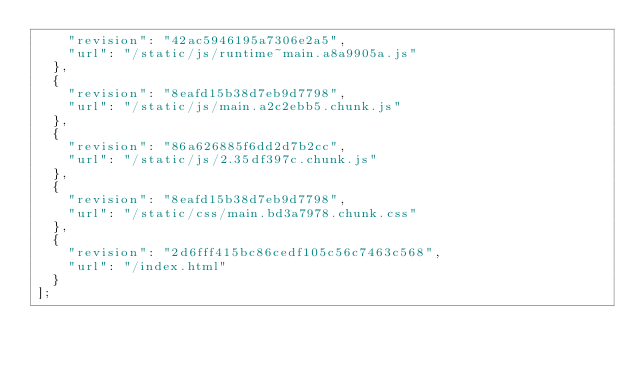Convert code to text. <code><loc_0><loc_0><loc_500><loc_500><_JavaScript_>    "revision": "42ac5946195a7306e2a5",
    "url": "/static/js/runtime~main.a8a9905a.js"
  },
  {
    "revision": "8eafd15b38d7eb9d7798",
    "url": "/static/js/main.a2c2ebb5.chunk.js"
  },
  {
    "revision": "86a626885f6dd2d7b2cc",
    "url": "/static/js/2.35df397c.chunk.js"
  },
  {
    "revision": "8eafd15b38d7eb9d7798",
    "url": "/static/css/main.bd3a7978.chunk.css"
  },
  {
    "revision": "2d6fff415bc86cedf105c56c7463c568",
    "url": "/index.html"
  }
];</code> 